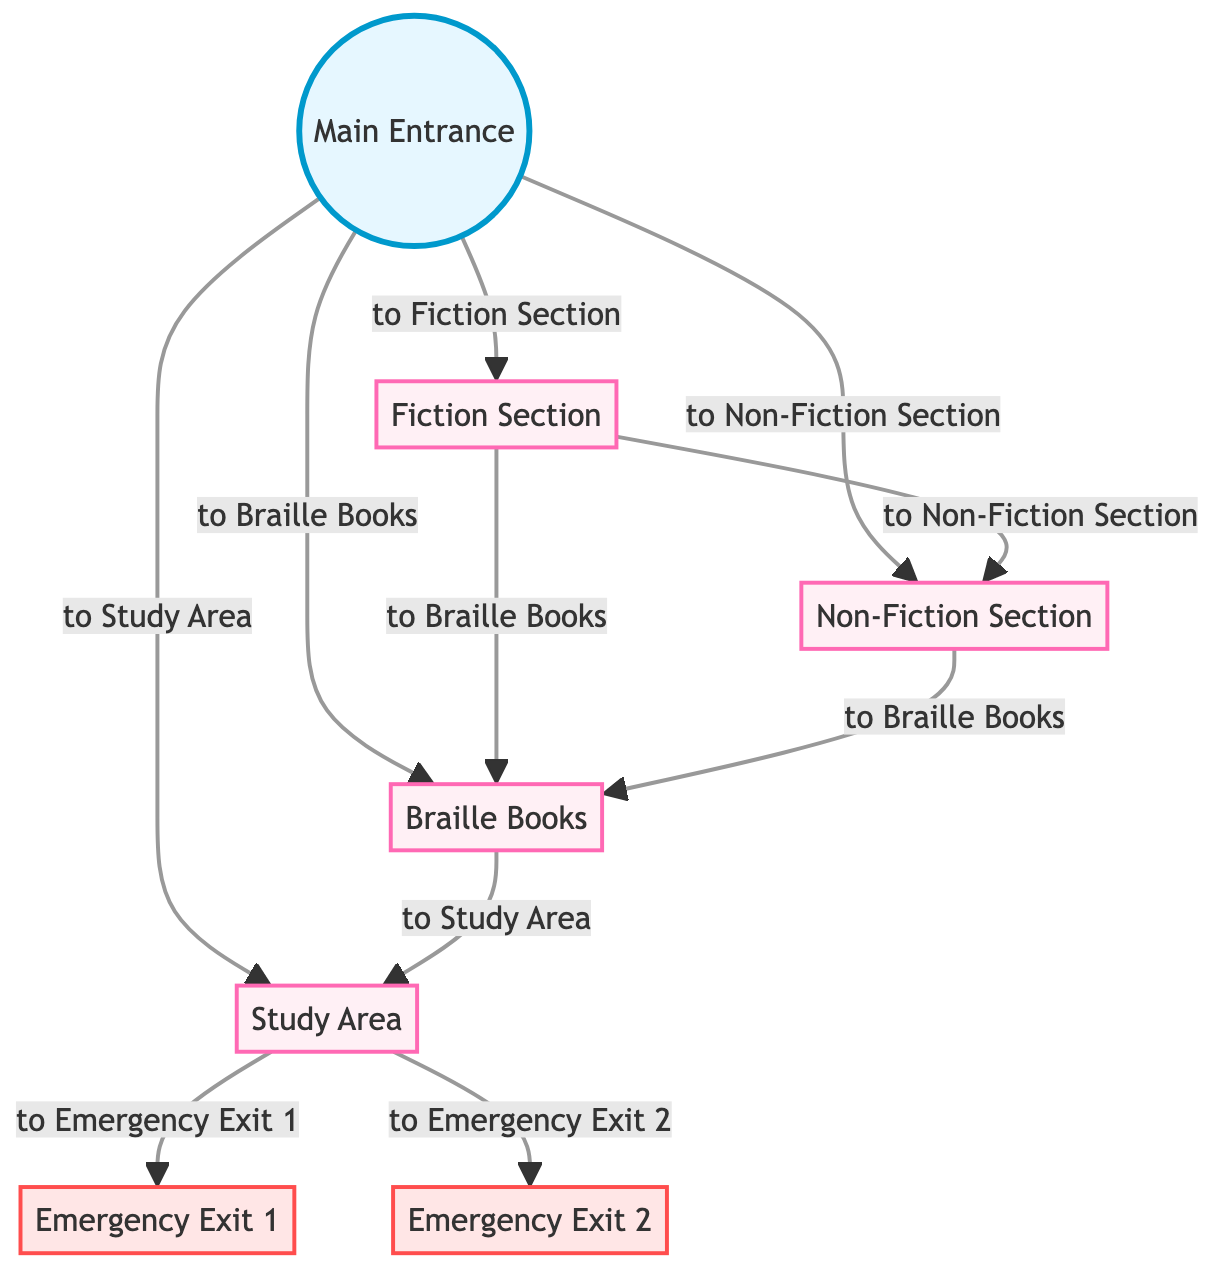What is the first section you reach upon entering the library? According to the diagram, the first section after the main entrance is the Fiction Section. This is indicated by the direct connection from the entrance to the fiction node.
Answer: Fiction Section How many sections are available in the library? The diagram lists four main sections: Fiction Section, Non-Fiction Section, Braille Books, and Study Area. This can be confirmed by counting the number of sections connected to the entrance.
Answer: Four Which section leads directly to the Study Area? The Study Area is reached directly from the Braille Books section, as indicated by the arrow connecting them in the diagram.
Answer: Braille Books What are the two emergency exits indicated in the diagram? The diagram shows Emergency Exit 1 and Emergency Exit 2, both linked from the Study Area. Therefore, these are the exits available for emergencies.
Answer: Emergency Exit 1 and Emergency Exit 2 Which section connects both the Fiction Section and the Non-Fiction Section? From the diagram, the connection shows that the Fiction Section can connect to the Non-Fiction Section directly. Thus, the Fiction Section serves as a bridge between these two sections.
Answer: Fiction Section If you are in the Study Area, what is your next immediate option for an exit? According to the diagram, if you are in the Study Area, the immediate options for exit are Emergency Exit 1 or Emergency Exit 2, which are directly connected to the Study Area node.
Answer: Emergency Exit 1 and Emergency Exit 2 What sections can be visited from the main entrance? The main entrance provides direct access to four sections: Fiction Section, Non-Fiction Section, Braille Books, and Study Area. All these sections are connected to the entrance in the diagram.
Answer: Fiction Section, Non-Fiction Section, Braille Books, Study Area Which section lines connect to the Braille Books section? The Braille Books section connects to three sections: Fiction Section, Non-Fiction Section, and Study Area, as indicated by the outgoing arrows from the Braille Books node to these sections.
Answer: Fiction Section, Non-Fiction Section, Study Area What is the relationship between the Fiction Section and the Braille Books? The diagram shows that there is a direct connection from the Fiction Section to the Braille Books section, indicating that one can navigate from fiction to braille books directly.
Answer: Direct connection 